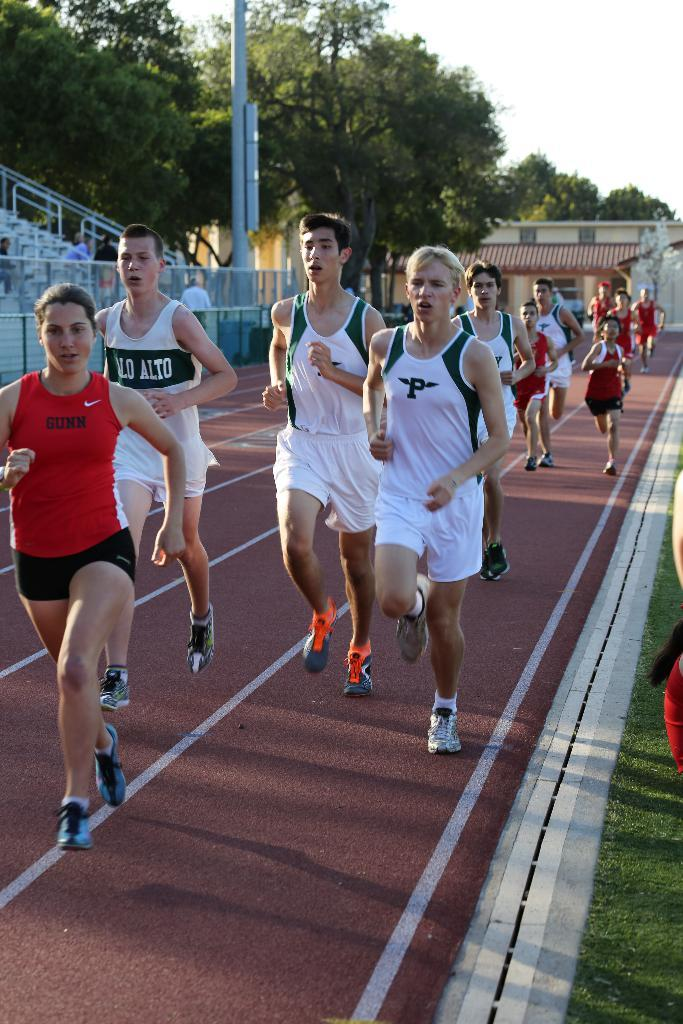What are the people in the image doing? The people in the image are running. What can be seen in the background of the image? There is fencing, poles, buildings, trees, and grass in the image. Can you describe the location of the grass in the image? The grass is located in the bottom right corner of the image. What type of question can be seen being asked in the image? There is no question visible in the image; it features people running and various background elements. What kind of plants are growing in the basin in the image? There is no basin or plants present in the image. 